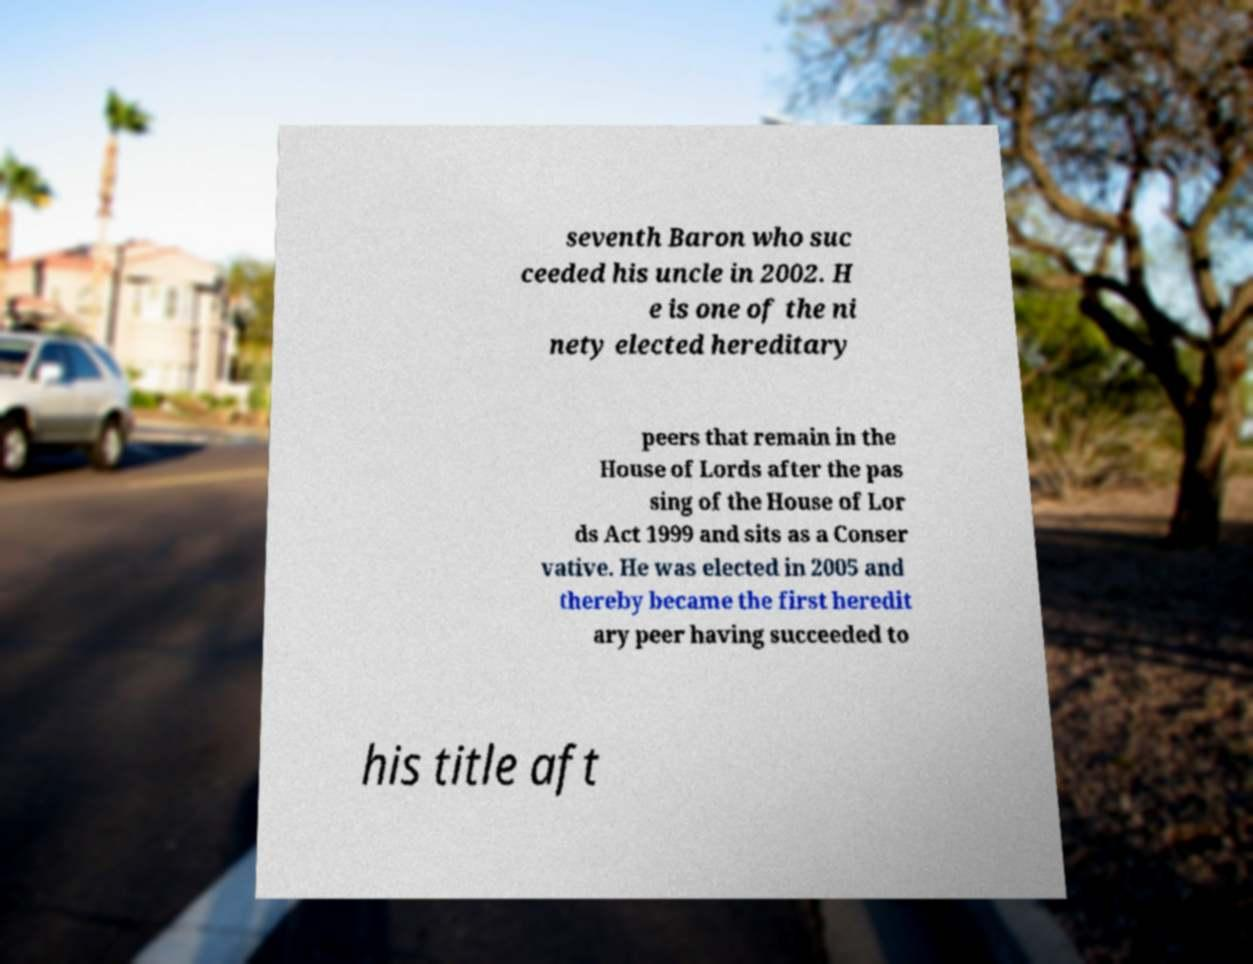Please read and relay the text visible in this image. What does it say? seventh Baron who suc ceeded his uncle in 2002. H e is one of the ni nety elected hereditary peers that remain in the House of Lords after the pas sing of the House of Lor ds Act 1999 and sits as a Conser vative. He was elected in 2005 and thereby became the first heredit ary peer having succeeded to his title aft 